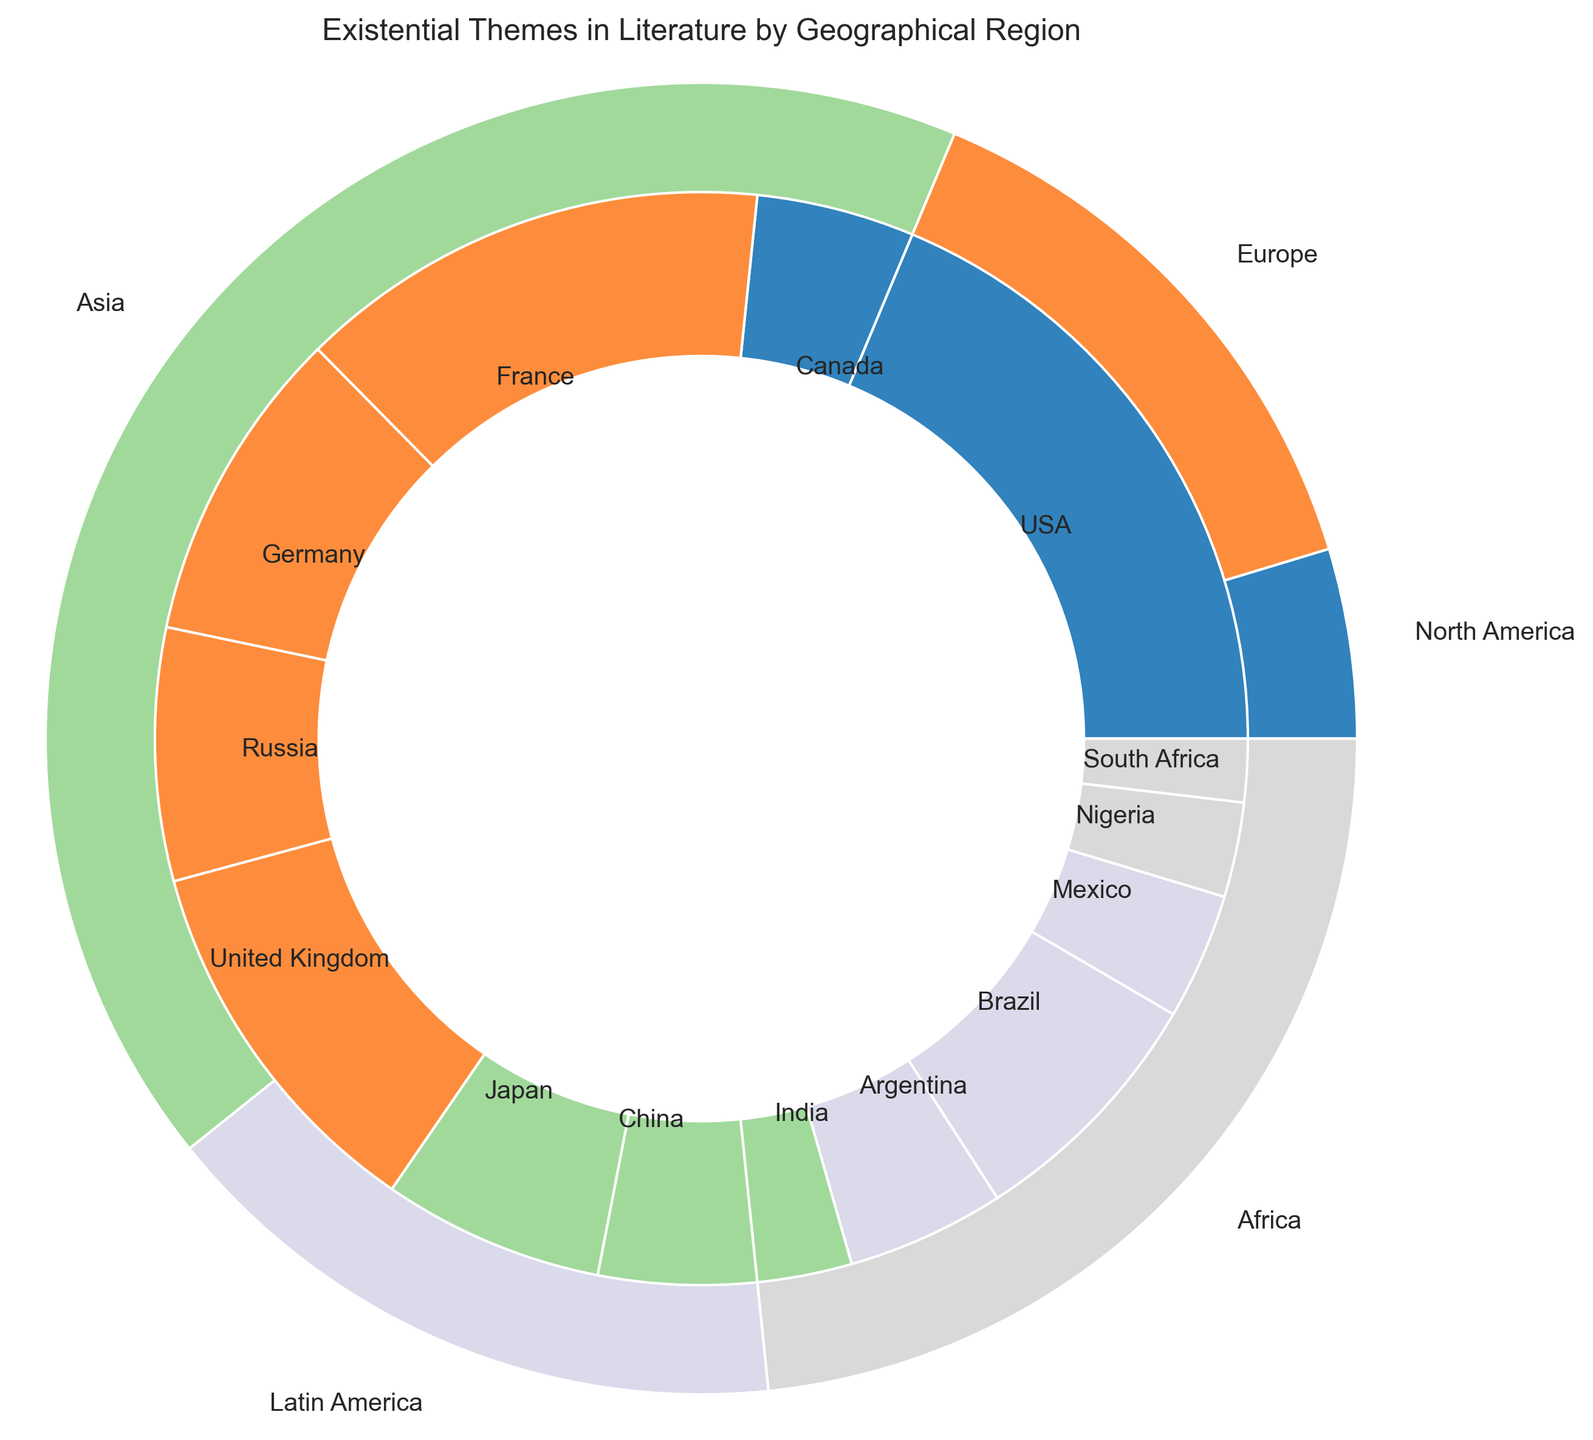How many countries are included from the North America region? To determine the number of countries from North America, we look at the breakdown in the figure. North America includes the USA and Canada. Thus, there are 2 countries within the North America region.
Answer: 2 Which country in Europe has the highest percentage and what is that percentage? Analyzing the slices within the European region, the country with the highest percentage is France, with 15%.
Answer: France, 15% What is the combined percentage of literature with existential themes from the Asia and Africa regions? To find the combined percentage, add the total percentage values of the countries within Asia and Africa: (7 + 5 + 3) for Asia and (3 + 2) for Africa. The sum is 15% + 5% = 20%.
Answer: 20% Is the contribution of the USA higher than the contribution of all Latin American countries combined? The USA has a percentage of 20%. The combined percentage of Latin American countries (Argentina, Brazil, and Mexico) is (5 + 8 + 4) = 17%. Thus, the USA's contribution is higher.
Answer: Yes What percentage of existential literature themes comes from the European region? By analyzing the outer pie chart, we sum up the percentages of all European countries: (15 + 10 + 8 + 12) = 45%.
Answer: 45% How does the contribution of the United Kingdom compare to that of Germany? The United Kingdom has a percentage of 12%, whereas Germany has 10%. Therefore, the United Kingdom's contribution is higher.
Answer: United Kingdom Which region has the least contribution in terms of existential literature themes, and what is the total percentage contribution of this region? By comparing the outer slices of the pie chart, Africa has the smallest slices. Summing up the percentages for Africa (Nigeria 3% + South Africa 2%) gives a total of 5%. This is the smallest percentage among all regions.
Answer: Africa, 5% What is the difference in percentage between the contributions of Japan and the United Kingdom? The percentage for Japan is 7%, and for the United Kingdom is 12%. The difference between these percentages is 12% - 7% = 5%.
Answer: 5% How many regions contribute more than 10% of the total existential literature themes? Checking the outer pie chart, regions contributing more than 10% include North America (USA 20% + Canada 5% = 25%) and Europe (45%). Thus, there are 2 regions contributing more than 10%.
Answer: 2 